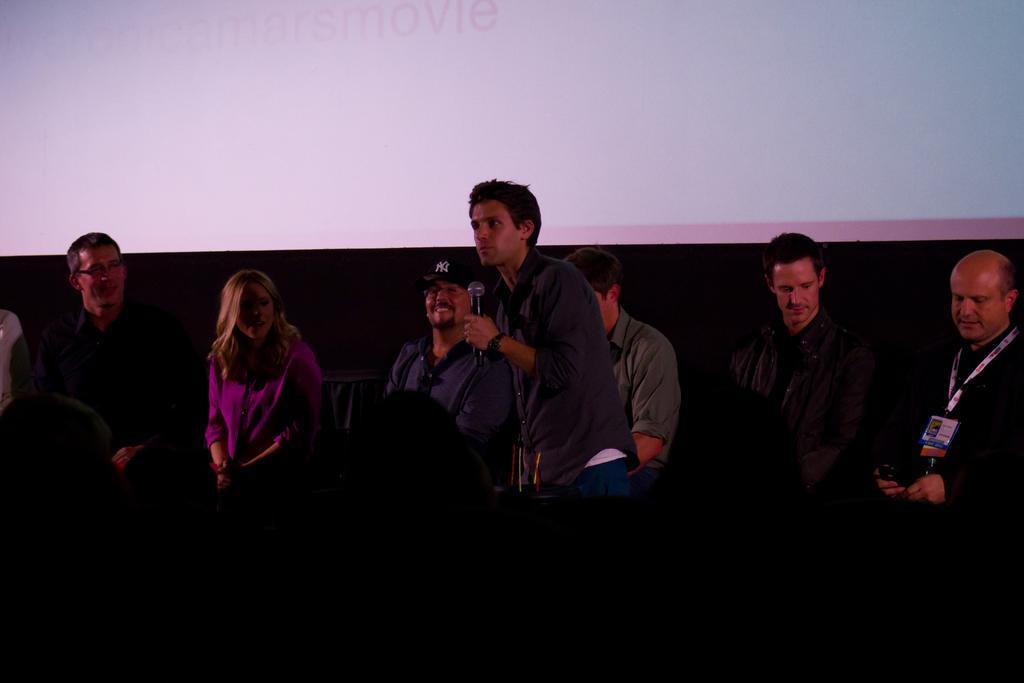Describe this image in one or two sentences. In the foreground of this picture, there is man holding a mic and around him there are persons sitting. In the background, there is a screen. 